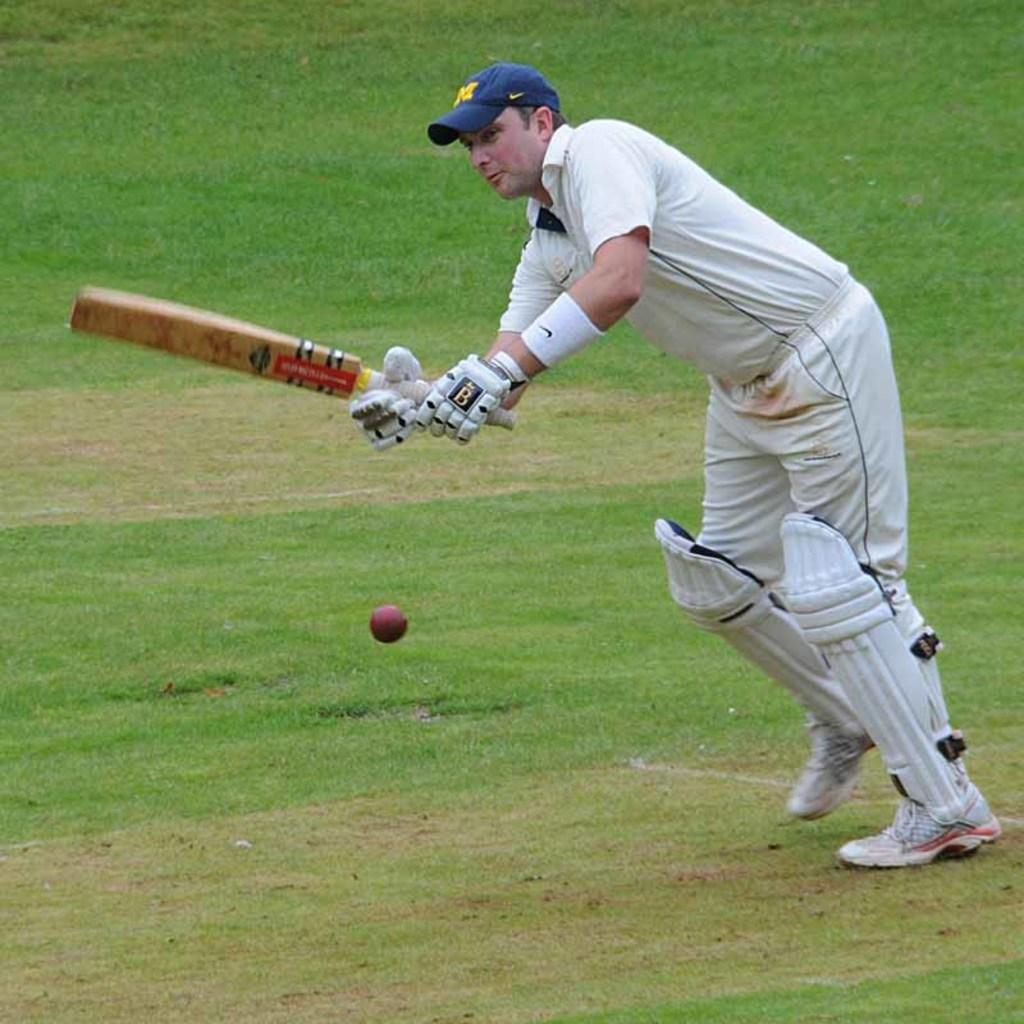What is the person in the image doing? The person is playing cricket. What can be seen in the background of the image? The cricket ground is visible in the image. What color is the person's cap? The person is wearing a blue cap. What color is the person's dress? The person is wearing a white dress. What type of fiction is the person reading in the image? There is no book or any form of reading material present in the image. 